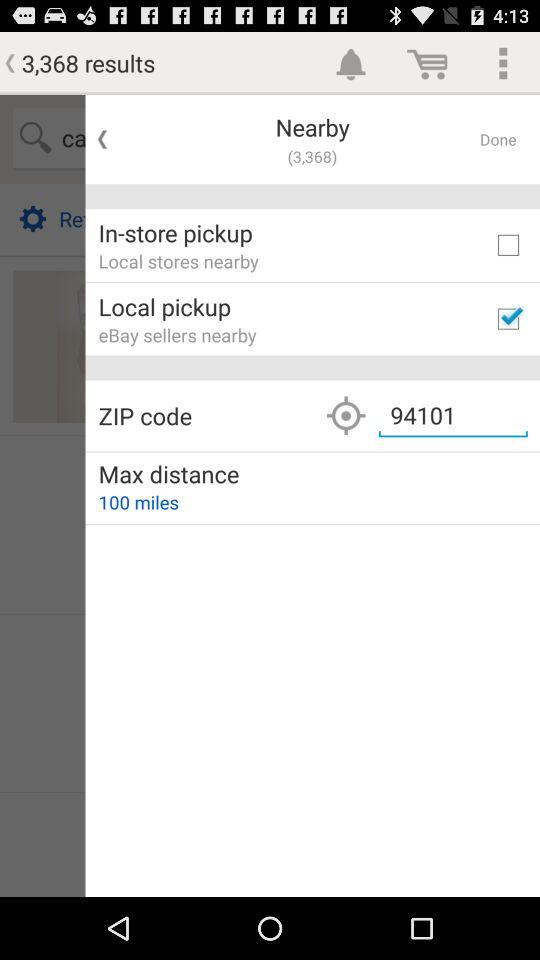Where is the nearest store location?
When the provided information is insufficient, respond with <no answer>. <no answer> 